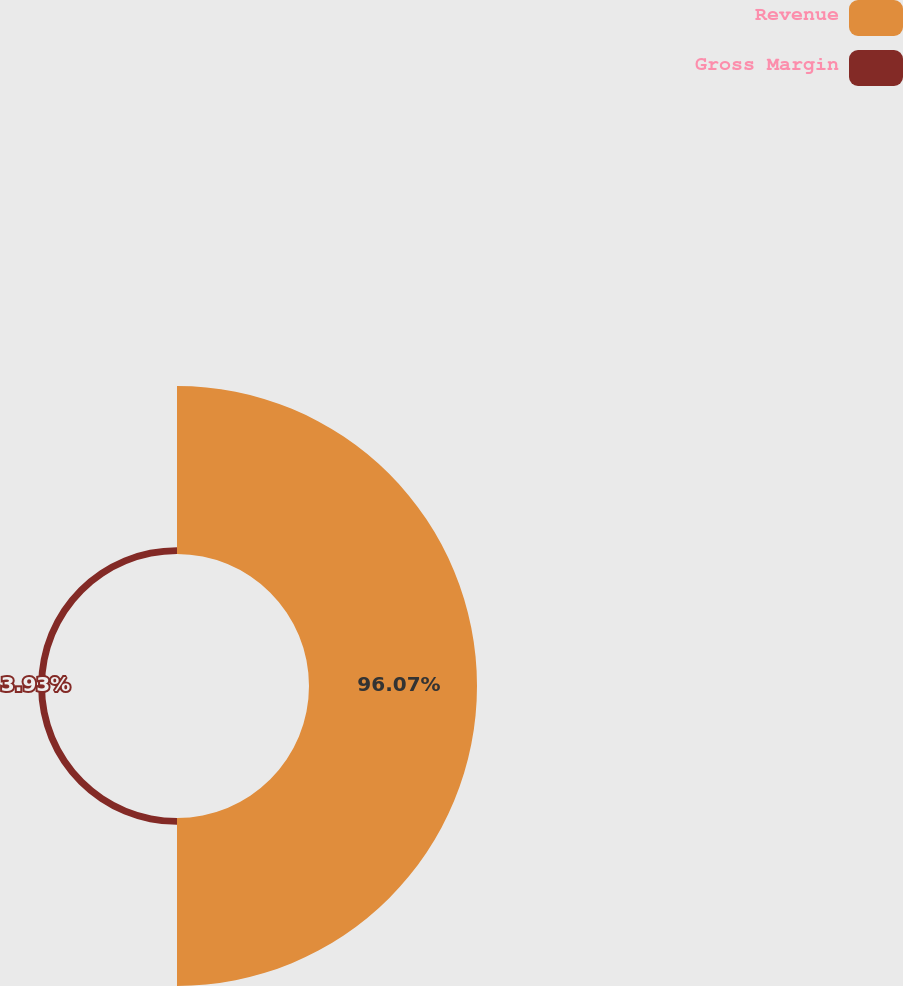Convert chart to OTSL. <chart><loc_0><loc_0><loc_500><loc_500><pie_chart><fcel>Revenue<fcel>Gross Margin<nl><fcel>96.07%<fcel>3.93%<nl></chart> 